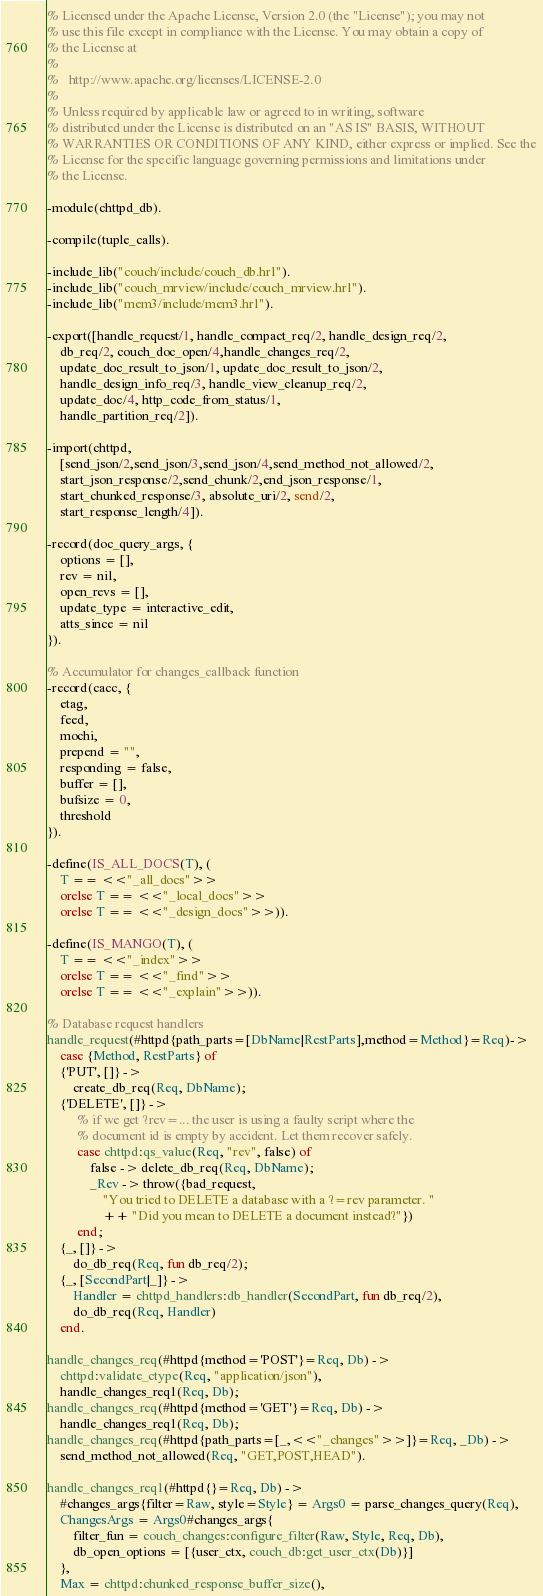Convert code to text. <code><loc_0><loc_0><loc_500><loc_500><_Erlang_>% Licensed under the Apache License, Version 2.0 (the "License"); you may not
% use this file except in compliance with the License. You may obtain a copy of
% the License at
%
%   http://www.apache.org/licenses/LICENSE-2.0
%
% Unless required by applicable law or agreed to in writing, software
% distributed under the License is distributed on an "AS IS" BASIS, WITHOUT
% WARRANTIES OR CONDITIONS OF ANY KIND, either express or implied. See the
% License for the specific language governing permissions and limitations under
% the License.

-module(chttpd_db).

-compile(tuple_calls).

-include_lib("couch/include/couch_db.hrl").
-include_lib("couch_mrview/include/couch_mrview.hrl").
-include_lib("mem3/include/mem3.hrl").

-export([handle_request/1, handle_compact_req/2, handle_design_req/2,
    db_req/2, couch_doc_open/4,handle_changes_req/2,
    update_doc_result_to_json/1, update_doc_result_to_json/2,
    handle_design_info_req/3, handle_view_cleanup_req/2,
    update_doc/4, http_code_from_status/1,
    handle_partition_req/2]).

-import(chttpd,
    [send_json/2,send_json/3,send_json/4,send_method_not_allowed/2,
    start_json_response/2,send_chunk/2,end_json_response/1,
    start_chunked_response/3, absolute_uri/2, send/2,
    start_response_length/4]).

-record(doc_query_args, {
    options = [],
    rev = nil,
    open_revs = [],
    update_type = interactive_edit,
    atts_since = nil
}).

% Accumulator for changes_callback function
-record(cacc, {
    etag,
    feed,
    mochi,
    prepend = "",
    responding = false,
    buffer = [],
    bufsize = 0,
    threshold
}).

-define(IS_ALL_DOCS(T), (
    T == <<"_all_docs">>
    orelse T == <<"_local_docs">>
    orelse T == <<"_design_docs">>)).

-define(IS_MANGO(T), (
    T == <<"_index">>
    orelse T == <<"_find">>
    orelse T == <<"_explain">>)).

% Database request handlers
handle_request(#httpd{path_parts=[DbName|RestParts],method=Method}=Req)->
    case {Method, RestParts} of
    {'PUT', []} ->
        create_db_req(Req, DbName);
    {'DELETE', []} ->
         % if we get ?rev=... the user is using a faulty script where the
         % document id is empty by accident. Let them recover safely.
         case chttpd:qs_value(Req, "rev", false) of
             false -> delete_db_req(Req, DbName);
             _Rev -> throw({bad_request,
                 "You tried to DELETE a database with a ?=rev parameter. "
                 ++ "Did you mean to DELETE a document instead?"})
         end;
    {_, []} ->
        do_db_req(Req, fun db_req/2);
    {_, [SecondPart|_]} ->
        Handler = chttpd_handlers:db_handler(SecondPart, fun db_req/2),
        do_db_req(Req, Handler)
    end.

handle_changes_req(#httpd{method='POST'}=Req, Db) ->
    chttpd:validate_ctype(Req, "application/json"),
    handle_changes_req1(Req, Db);
handle_changes_req(#httpd{method='GET'}=Req, Db) ->
    handle_changes_req1(Req, Db);
handle_changes_req(#httpd{path_parts=[_,<<"_changes">>]}=Req, _Db) ->
    send_method_not_allowed(Req, "GET,POST,HEAD").

handle_changes_req1(#httpd{}=Req, Db) ->
    #changes_args{filter=Raw, style=Style} = Args0 = parse_changes_query(Req),
    ChangesArgs = Args0#changes_args{
        filter_fun = couch_changes:configure_filter(Raw, Style, Req, Db),
        db_open_options = [{user_ctx, couch_db:get_user_ctx(Db)}]
    },
    Max = chttpd:chunked_response_buffer_size(),</code> 